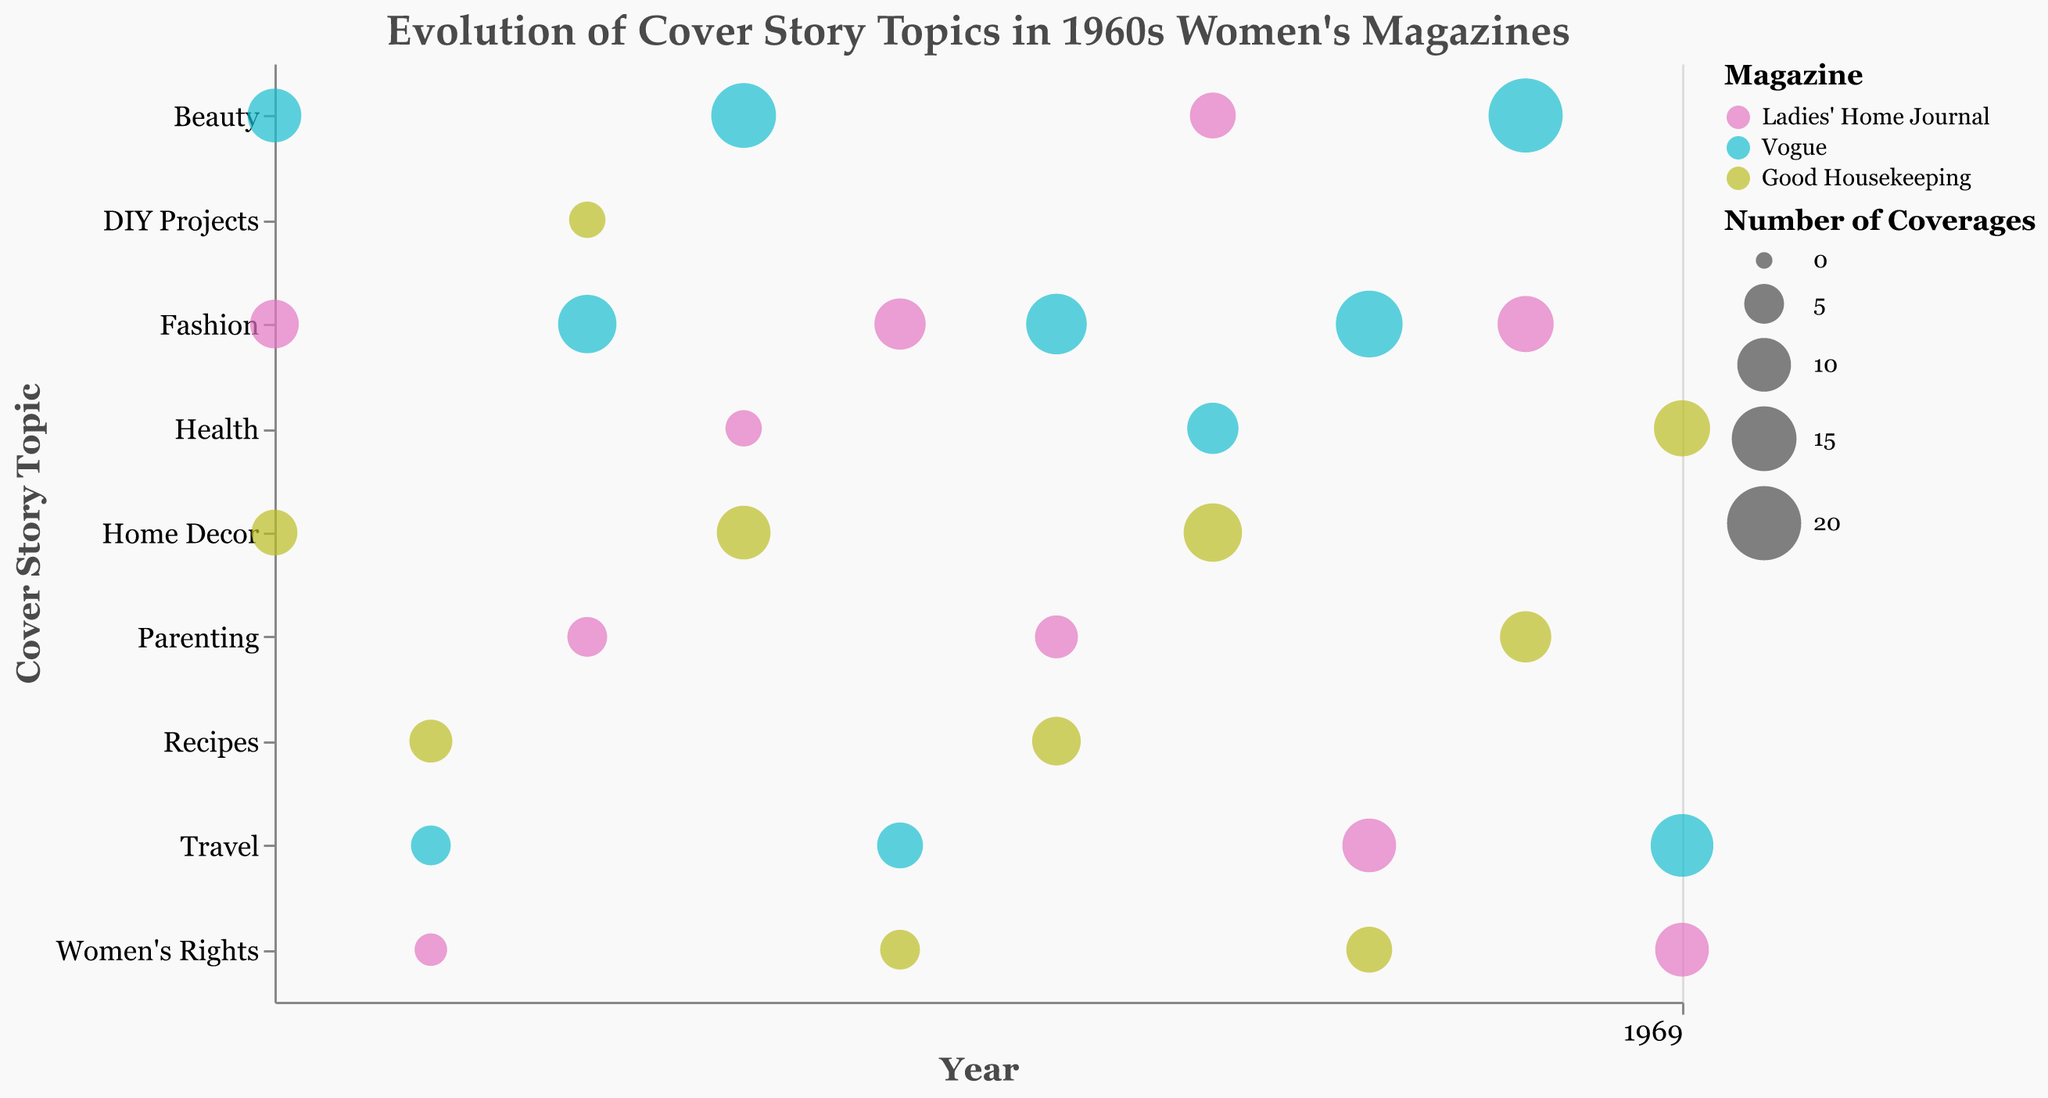What is the title of the Bubble Chart? The title of the chart is displayed at the top of the figure in a larger font size and different color compared to other text. The title conveys the main subject or focus of the chart.
Answer: Evolution of Cover Story Topics in 1960s Women's Magazines How many times was "Women's Rights" covered in Ladies' Home Journal in 1969? Identify the year 1969 on the x-axis and find the corresponding bubble related to "Ladies' Home Journal" and the "Women's Rights" topic. Check the size of the bubble or use tooltip information for exact figures.
Answer: 10 Which magazine had the highest number of coverages in 1963 for the topic of "Beauty"? Locate the line corresponding to the year 1963 on the x-axis, then find the row associated with the "Beauty" topic. Identify the magazine represented by the largest bubble or use tooltip for precise numbers.
Answer: Vogue What were the cover story topics and their influence scores for Good Housekeeping in 1966? Focus on the year 1966 on the x-axis, identify the bubbles for "Good Housekeeping" by their color, and use tooltips to see the topics and influence scores.
Answer: Home Decor, 8 How did the coverage of "Fashion" evolve over the decade for Vogue? Track the bubbles along the y-axis for the "Fashion" topic and follow the color representing Vogue across the timeline. Look at the changes in bubble sizes by year. Calculate any visible trends in frequency.
Answer: Increased significantly, especially from 1962 to 1967 In which year did "Travel" topics peak for Vogue and what was the influence score? Observe the timeline and the bubbles corresponding to the "Travel" topic in the color assigned to Vogue. Identify the largest bubble for the topic and read off the year and influence score using tooltips.
Answer: 1969, 8 Compare the influence scores of "Health" topics between Ladies' Home Journal and Good Housekeeping in 1966. Which magazine had a higher influence score? Locate 1966 on the x-axis, find the color-coded bubbles for "Health" topics for both magazines, then compare their influence scores using tooltips.
Answer: Ladies' Home Journal had a score of 7, while Good Housekeeping had a score of 8 How many topics does Vogue have more than 10 coverages of in 1968? Focus on the year 1968, identify the color-coded bubbles for Vogue, and count how many exceed a size that denotes 10 coverages. Use tooltip for exact figures.
Answer: 1 (Beauty) What is the combined influence score of "Women's Rights" topics in 1967 across all magazines? Identify the bubbles representing "Women's Rights" in 1967, regardless of color, and sum their influence scores. Use tooltips for accurate data.
Answer: 9 (Ladies' Home Journal) + 7 (Good Housekeeping) = 16 